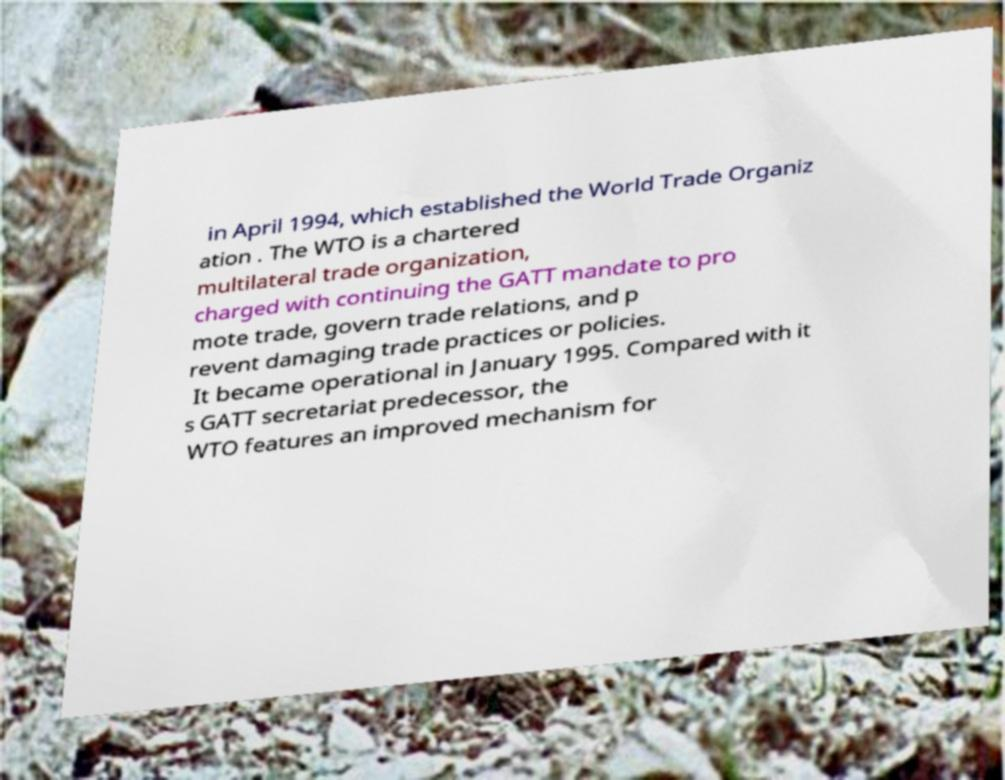I need the written content from this picture converted into text. Can you do that? in April 1994, which established the World Trade Organiz ation . The WTO is a chartered multilateral trade organization, charged with continuing the GATT mandate to pro mote trade, govern trade relations, and p revent damaging trade practices or policies. It became operational in January 1995. Compared with it s GATT secretariat predecessor, the WTO features an improved mechanism for 